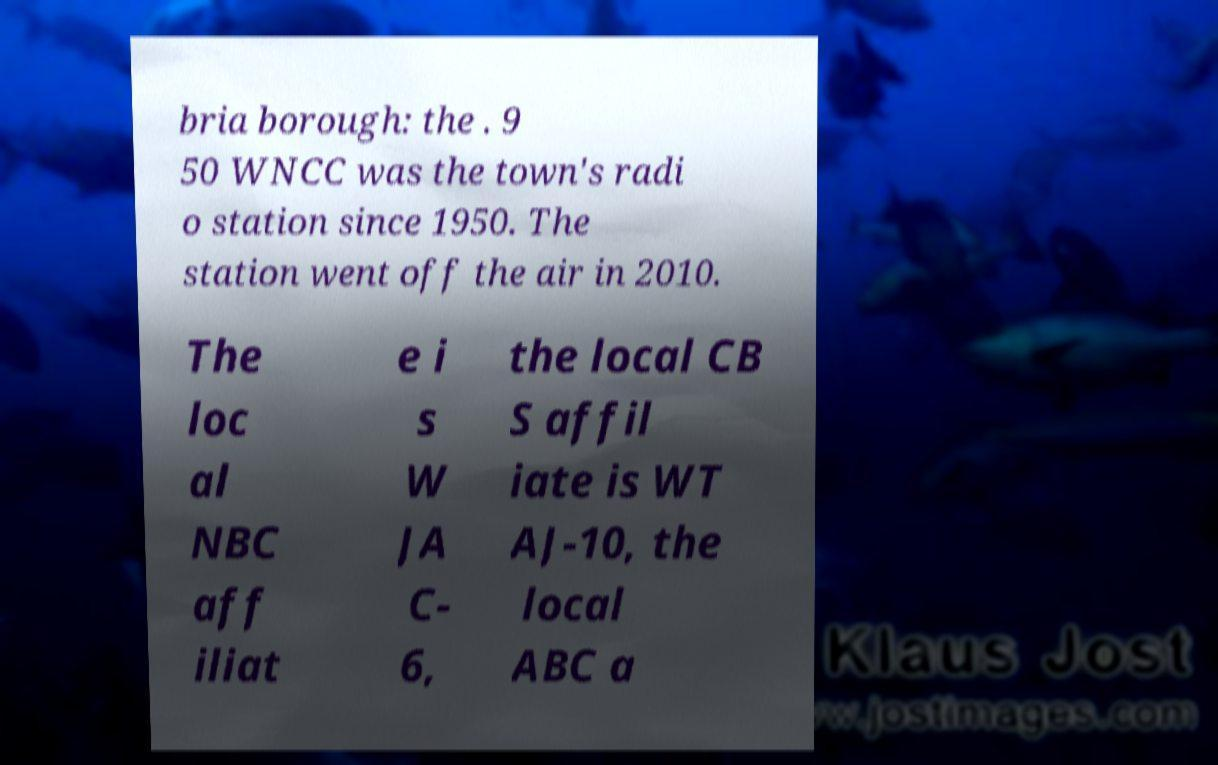What messages or text are displayed in this image? I need them in a readable, typed format. bria borough: the . 9 50 WNCC was the town's radi o station since 1950. The station went off the air in 2010. The loc al NBC aff iliat e i s W JA C- 6, the local CB S affil iate is WT AJ-10, the local ABC a 